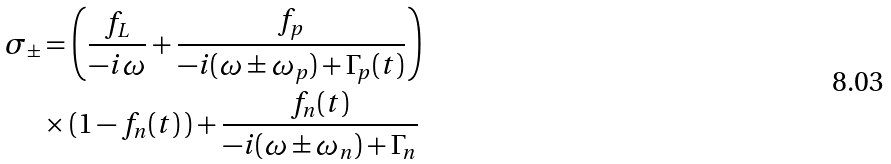Convert formula to latex. <formula><loc_0><loc_0><loc_500><loc_500>\sigma _ { \pm } & = \left ( \frac { f _ { L } } { - i \omega } + \frac { f _ { p } } { - i ( \omega \pm \omega _ { p } ) + \Gamma _ { p } ( t ) } \right ) \\ & \times ( 1 - f _ { n } ( t ) \, ) + \frac { f _ { n } ( t ) } { - i ( \omega \pm \omega _ { n } ) + \Gamma _ { n } }</formula> 